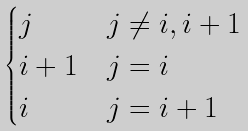<formula> <loc_0><loc_0><loc_500><loc_500>\begin{cases} j & j \ne i , i + 1 \\ i + 1 & j = i \\ i & j = i + 1 \end{cases}</formula> 